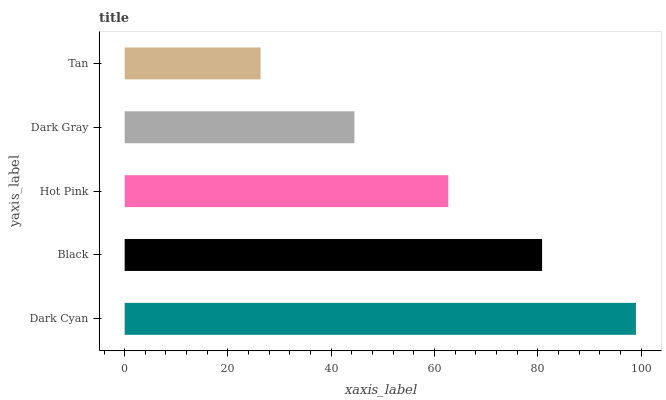Is Tan the minimum?
Answer yes or no. Yes. Is Dark Cyan the maximum?
Answer yes or no. Yes. Is Black the minimum?
Answer yes or no. No. Is Black the maximum?
Answer yes or no. No. Is Dark Cyan greater than Black?
Answer yes or no. Yes. Is Black less than Dark Cyan?
Answer yes or no. Yes. Is Black greater than Dark Cyan?
Answer yes or no. No. Is Dark Cyan less than Black?
Answer yes or no. No. Is Hot Pink the high median?
Answer yes or no. Yes. Is Hot Pink the low median?
Answer yes or no. Yes. Is Dark Cyan the high median?
Answer yes or no. No. Is Tan the low median?
Answer yes or no. No. 